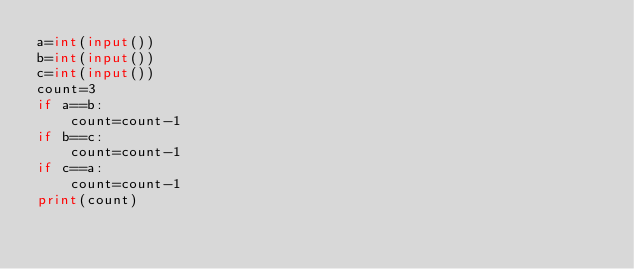<code> <loc_0><loc_0><loc_500><loc_500><_Python_>a=int(input())
b=int(input())
c=int(input())
count=3
if a==b:
    count=count-1
if b==c:
    count=count-1
if c==a:
    count=count-1
print(count)
</code> 